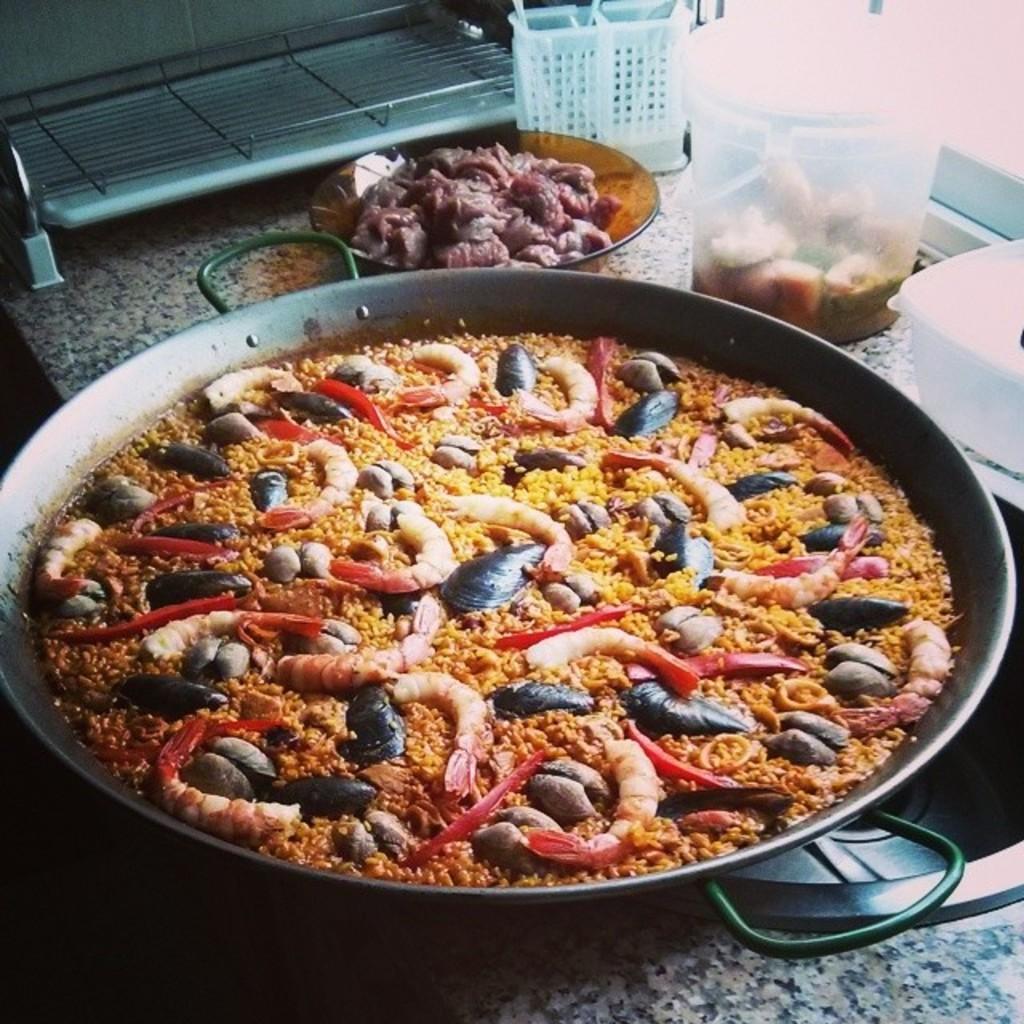Can you describe this image briefly? In the middle of this image, there are shrimps, shells and other food items arranged on a pan, which is on a table, on which there is a plate having meat, a basket, a box and other objects. In the background, there is a window. 